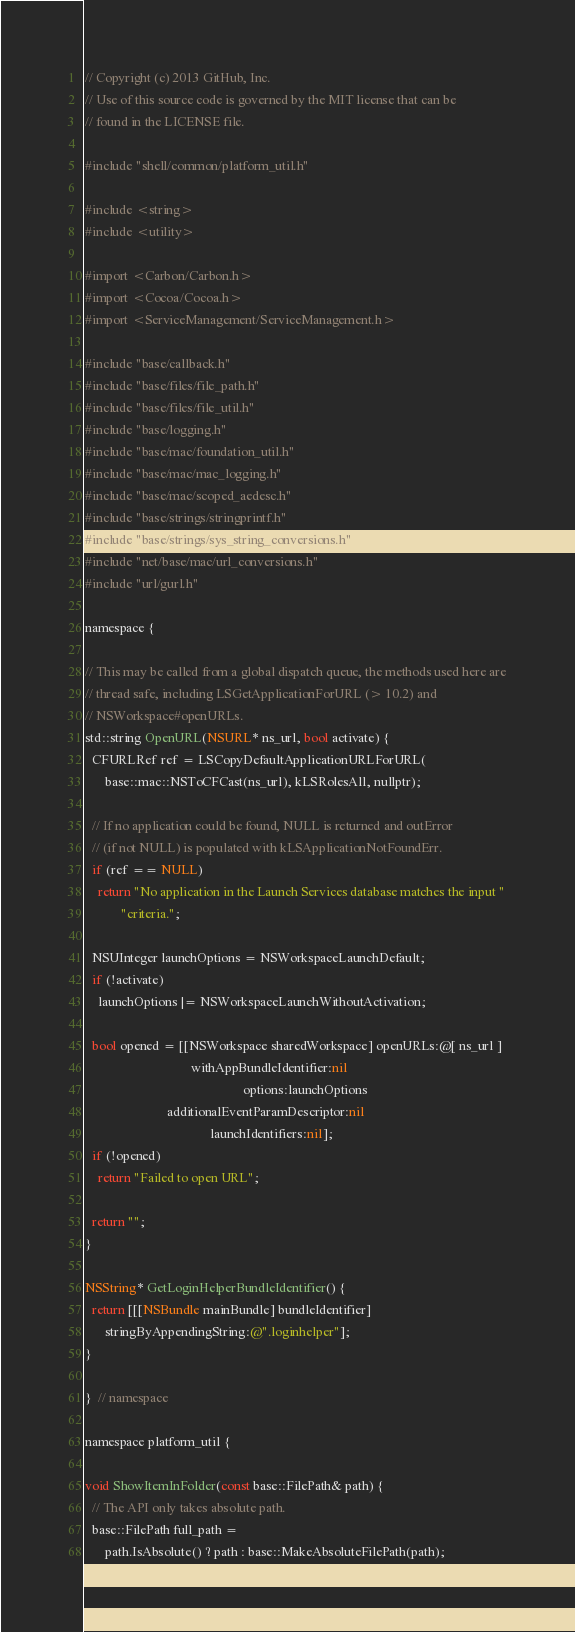<code> <loc_0><loc_0><loc_500><loc_500><_ObjectiveC_>// Copyright (c) 2013 GitHub, Inc.
// Use of this source code is governed by the MIT license that can be
// found in the LICENSE file.

#include "shell/common/platform_util.h"

#include <string>
#include <utility>

#import <Carbon/Carbon.h>
#import <Cocoa/Cocoa.h>
#import <ServiceManagement/ServiceManagement.h>

#include "base/callback.h"
#include "base/files/file_path.h"
#include "base/files/file_util.h"
#include "base/logging.h"
#include "base/mac/foundation_util.h"
#include "base/mac/mac_logging.h"
#include "base/mac/scoped_aedesc.h"
#include "base/strings/stringprintf.h"
#include "base/strings/sys_string_conversions.h"
#include "net/base/mac/url_conversions.h"
#include "url/gurl.h"

namespace {

// This may be called from a global dispatch queue, the methods used here are
// thread safe, including LSGetApplicationForURL (> 10.2) and
// NSWorkspace#openURLs.
std::string OpenURL(NSURL* ns_url, bool activate) {
  CFURLRef ref = LSCopyDefaultApplicationURLForURL(
      base::mac::NSToCFCast(ns_url), kLSRolesAll, nullptr);

  // If no application could be found, NULL is returned and outError
  // (if not NULL) is populated with kLSApplicationNotFoundErr.
  if (ref == NULL)
    return "No application in the Launch Services database matches the input "
           "criteria.";

  NSUInteger launchOptions = NSWorkspaceLaunchDefault;
  if (!activate)
    launchOptions |= NSWorkspaceLaunchWithoutActivation;

  bool opened = [[NSWorkspace sharedWorkspace] openURLs:@[ ns_url ]
                                withAppBundleIdentifier:nil
                                                options:launchOptions
                         additionalEventParamDescriptor:nil
                                      launchIdentifiers:nil];
  if (!opened)
    return "Failed to open URL";

  return "";
}

NSString* GetLoginHelperBundleIdentifier() {
  return [[[NSBundle mainBundle] bundleIdentifier]
      stringByAppendingString:@".loginhelper"];
}

}  // namespace

namespace platform_util {

void ShowItemInFolder(const base::FilePath& path) {
  // The API only takes absolute path.
  base::FilePath full_path =
      path.IsAbsolute() ? path : base::MakeAbsoluteFilePath(path);
</code> 